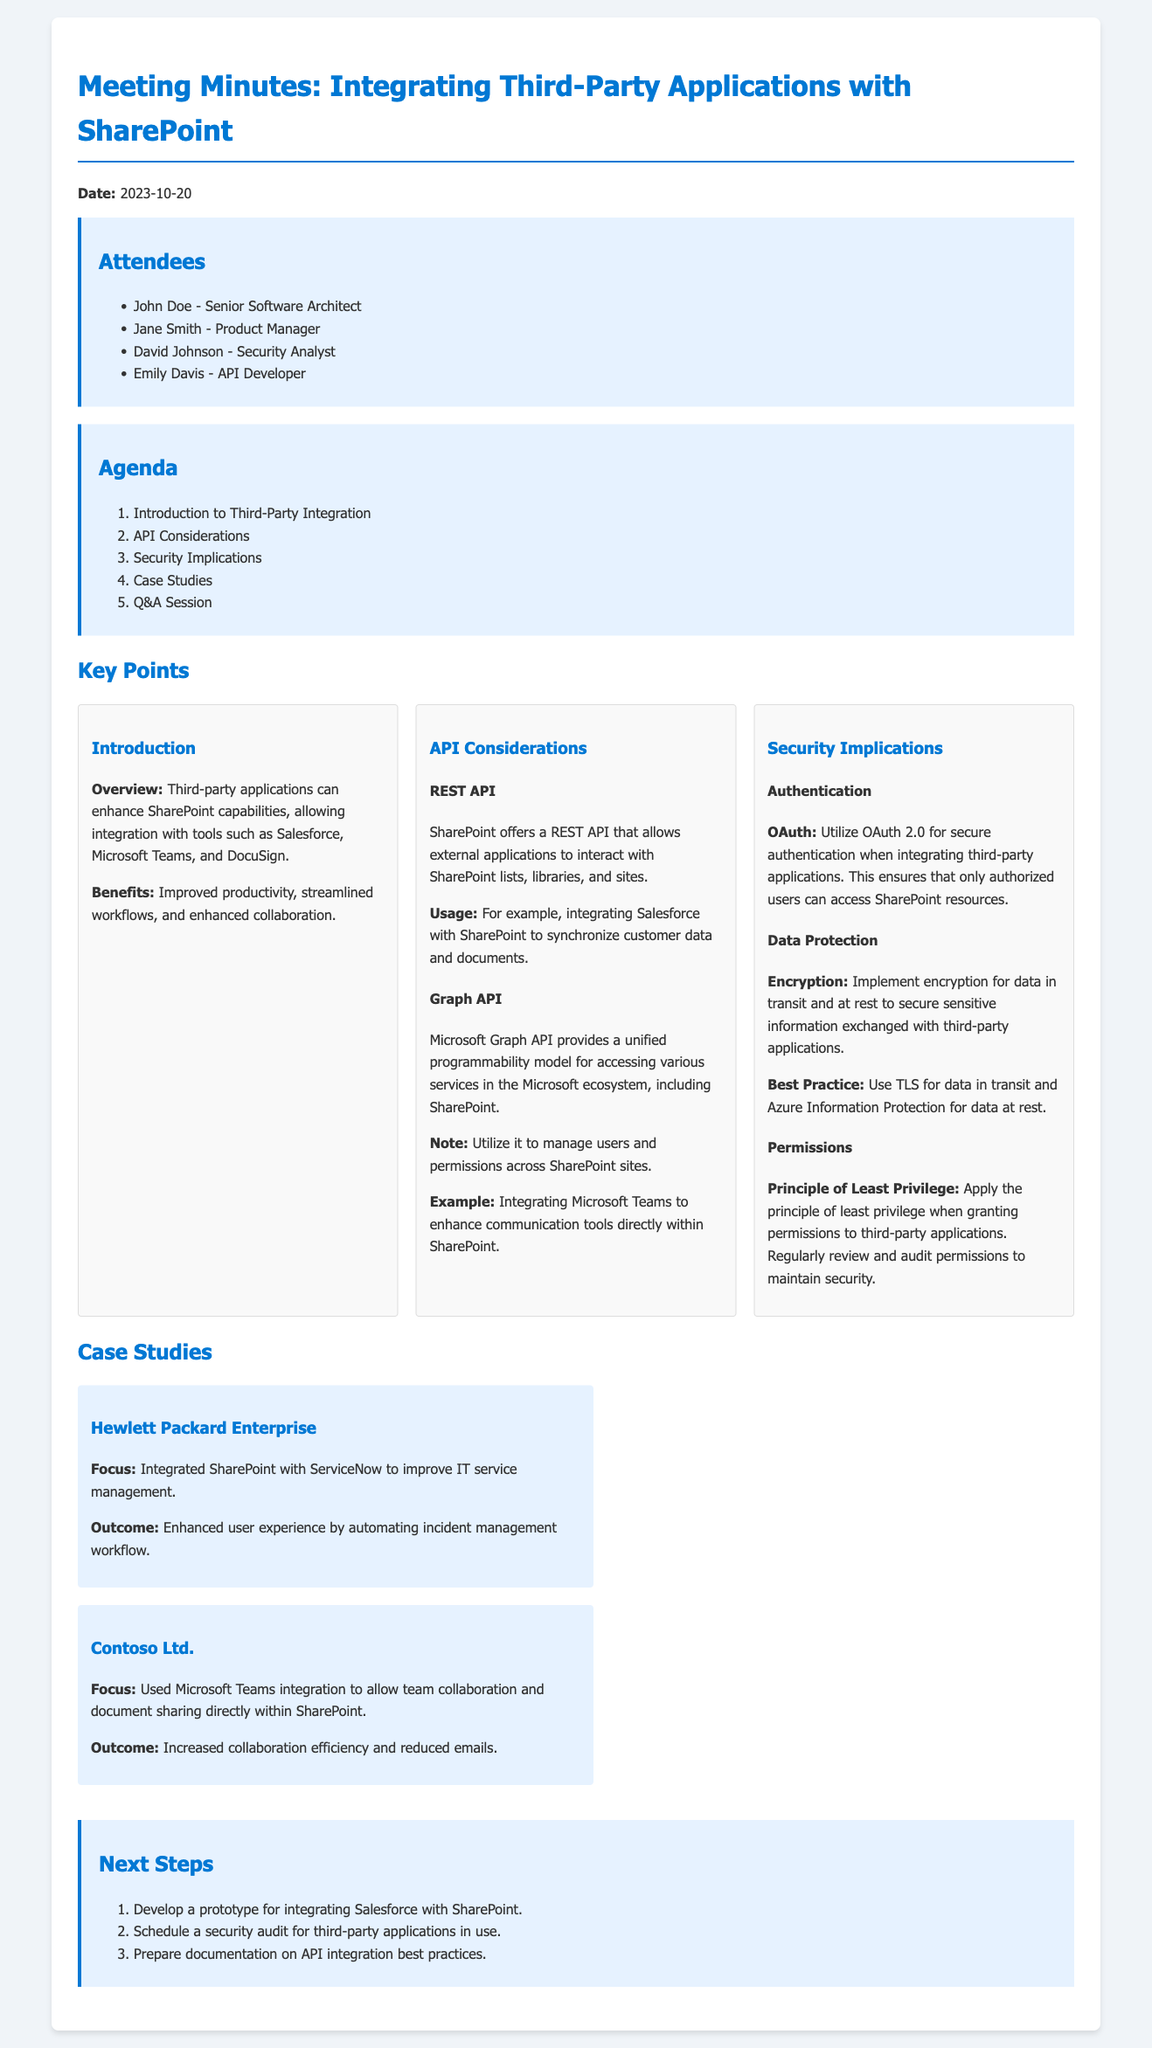what is the date of the meeting? The date of the meeting is explicitly stated at the beginning of the document.
Answer: 2023-10-20 who is the Senior Software Architect attending the meeting? The document lists the names of the attendees, including the Senior Software Architect.
Answer: John Doe what is one of the key benefits of third-party applications integration with SharePoint? The document discusses the benefits in the introduction section.
Answer: Improved productivity what is the authentication method recommended for third-party integrations? The recommended method is mentioned under the security implications section in the document.
Answer: OAuth 2.0 how many steps are outlined in the Next Steps section? The number of steps is specified in the list provided in the Next Steps section.
Answer: 3 what principle should be applied when granting permissions to third-party applications? This principle is discussed in the security implications section regarding permissions.
Answer: Least Privilege which API allows external applications to interact with SharePoint lists? The relevant API used for interaction with SharePoint is mentioned in the API considerations section.
Answer: REST API what case study focused on integrating SharePoint with ServiceNow? The case study is detailed in the Case Studies section of the document.
Answer: Hewlett Packard Enterprise what is the main focus of Contoso Ltd.'s case study? The focus of the case study is explicitly mentioned in the description.
Answer: Microsoft Teams integration 